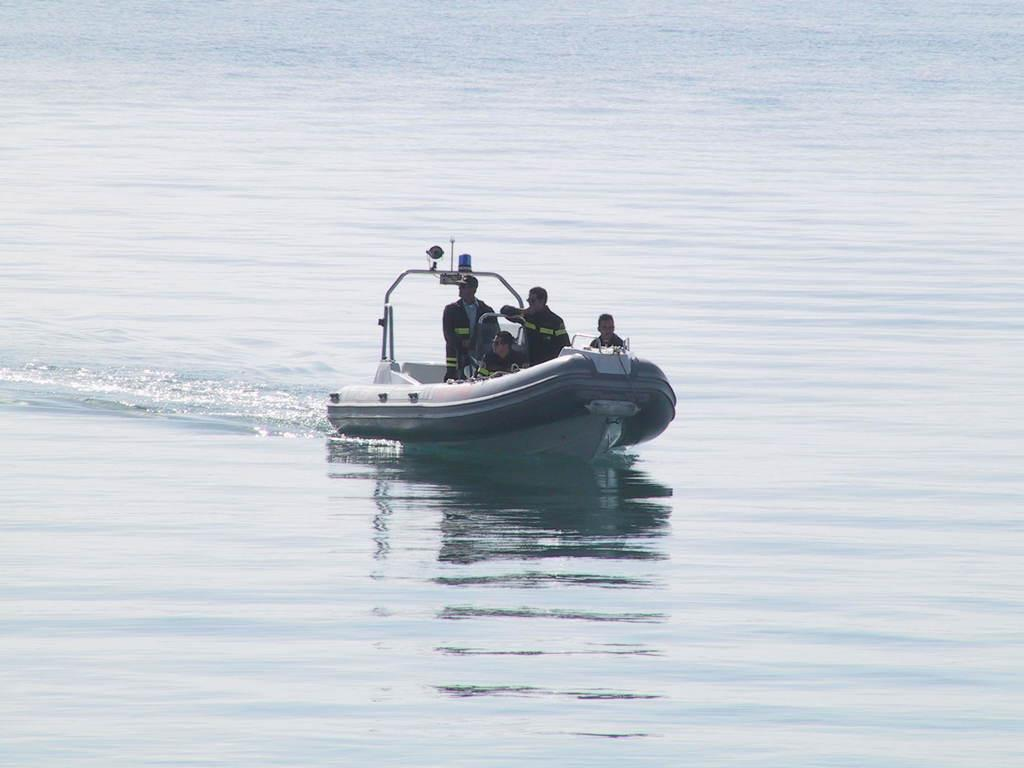What is the main subject of the image? The main subject of the image is a boat. Where is the boat located? The boat is in a lake. Are there any people in the boat? Yes, there are people in the boat. How many people are in the boat? There are people standing and one person sitting in the boat. What type of branch can be seen growing from the boat in the image? There is no branch growing from the boat in the image. 